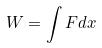Convert formula to latex. <formula><loc_0><loc_0><loc_500><loc_500>W = \int F d x</formula> 